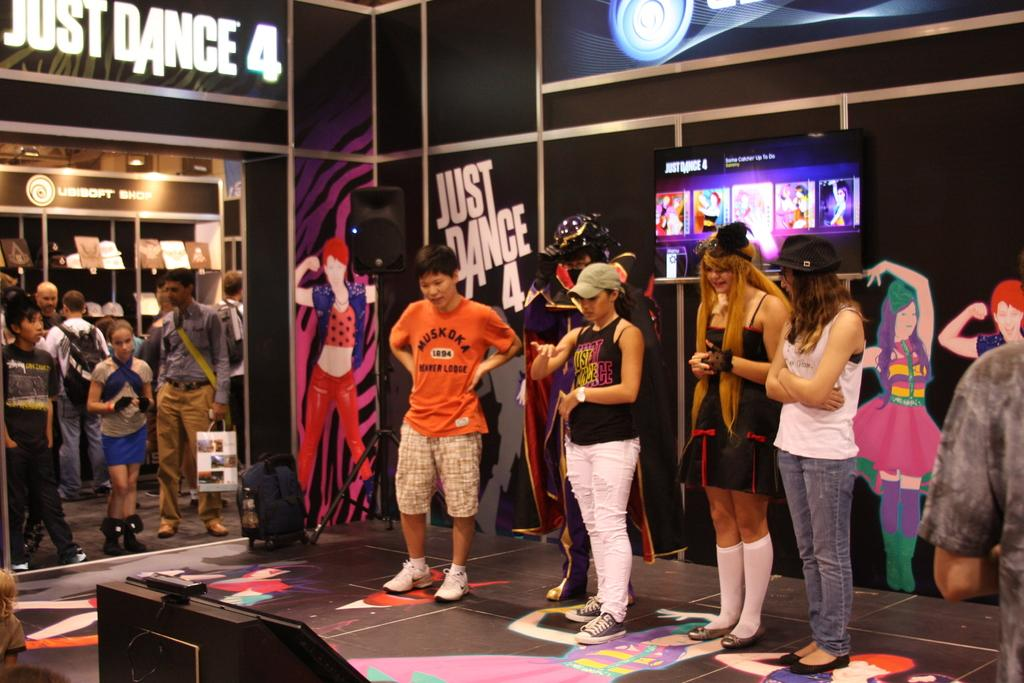What can be seen in the foreground of the image? There are people standing in the foreground of the image. What is visible on the wall in the background? There are posters on the wall in the background. What else can be seen in the background of the image? There are other people and objects in the background of the image. What type of beef is being served in the image? There is no beef present in the image. What time of day is it in the image, based on the hour? The provided facts do not mention the time of day or any specific hour, so it cannot be determined from the image. 